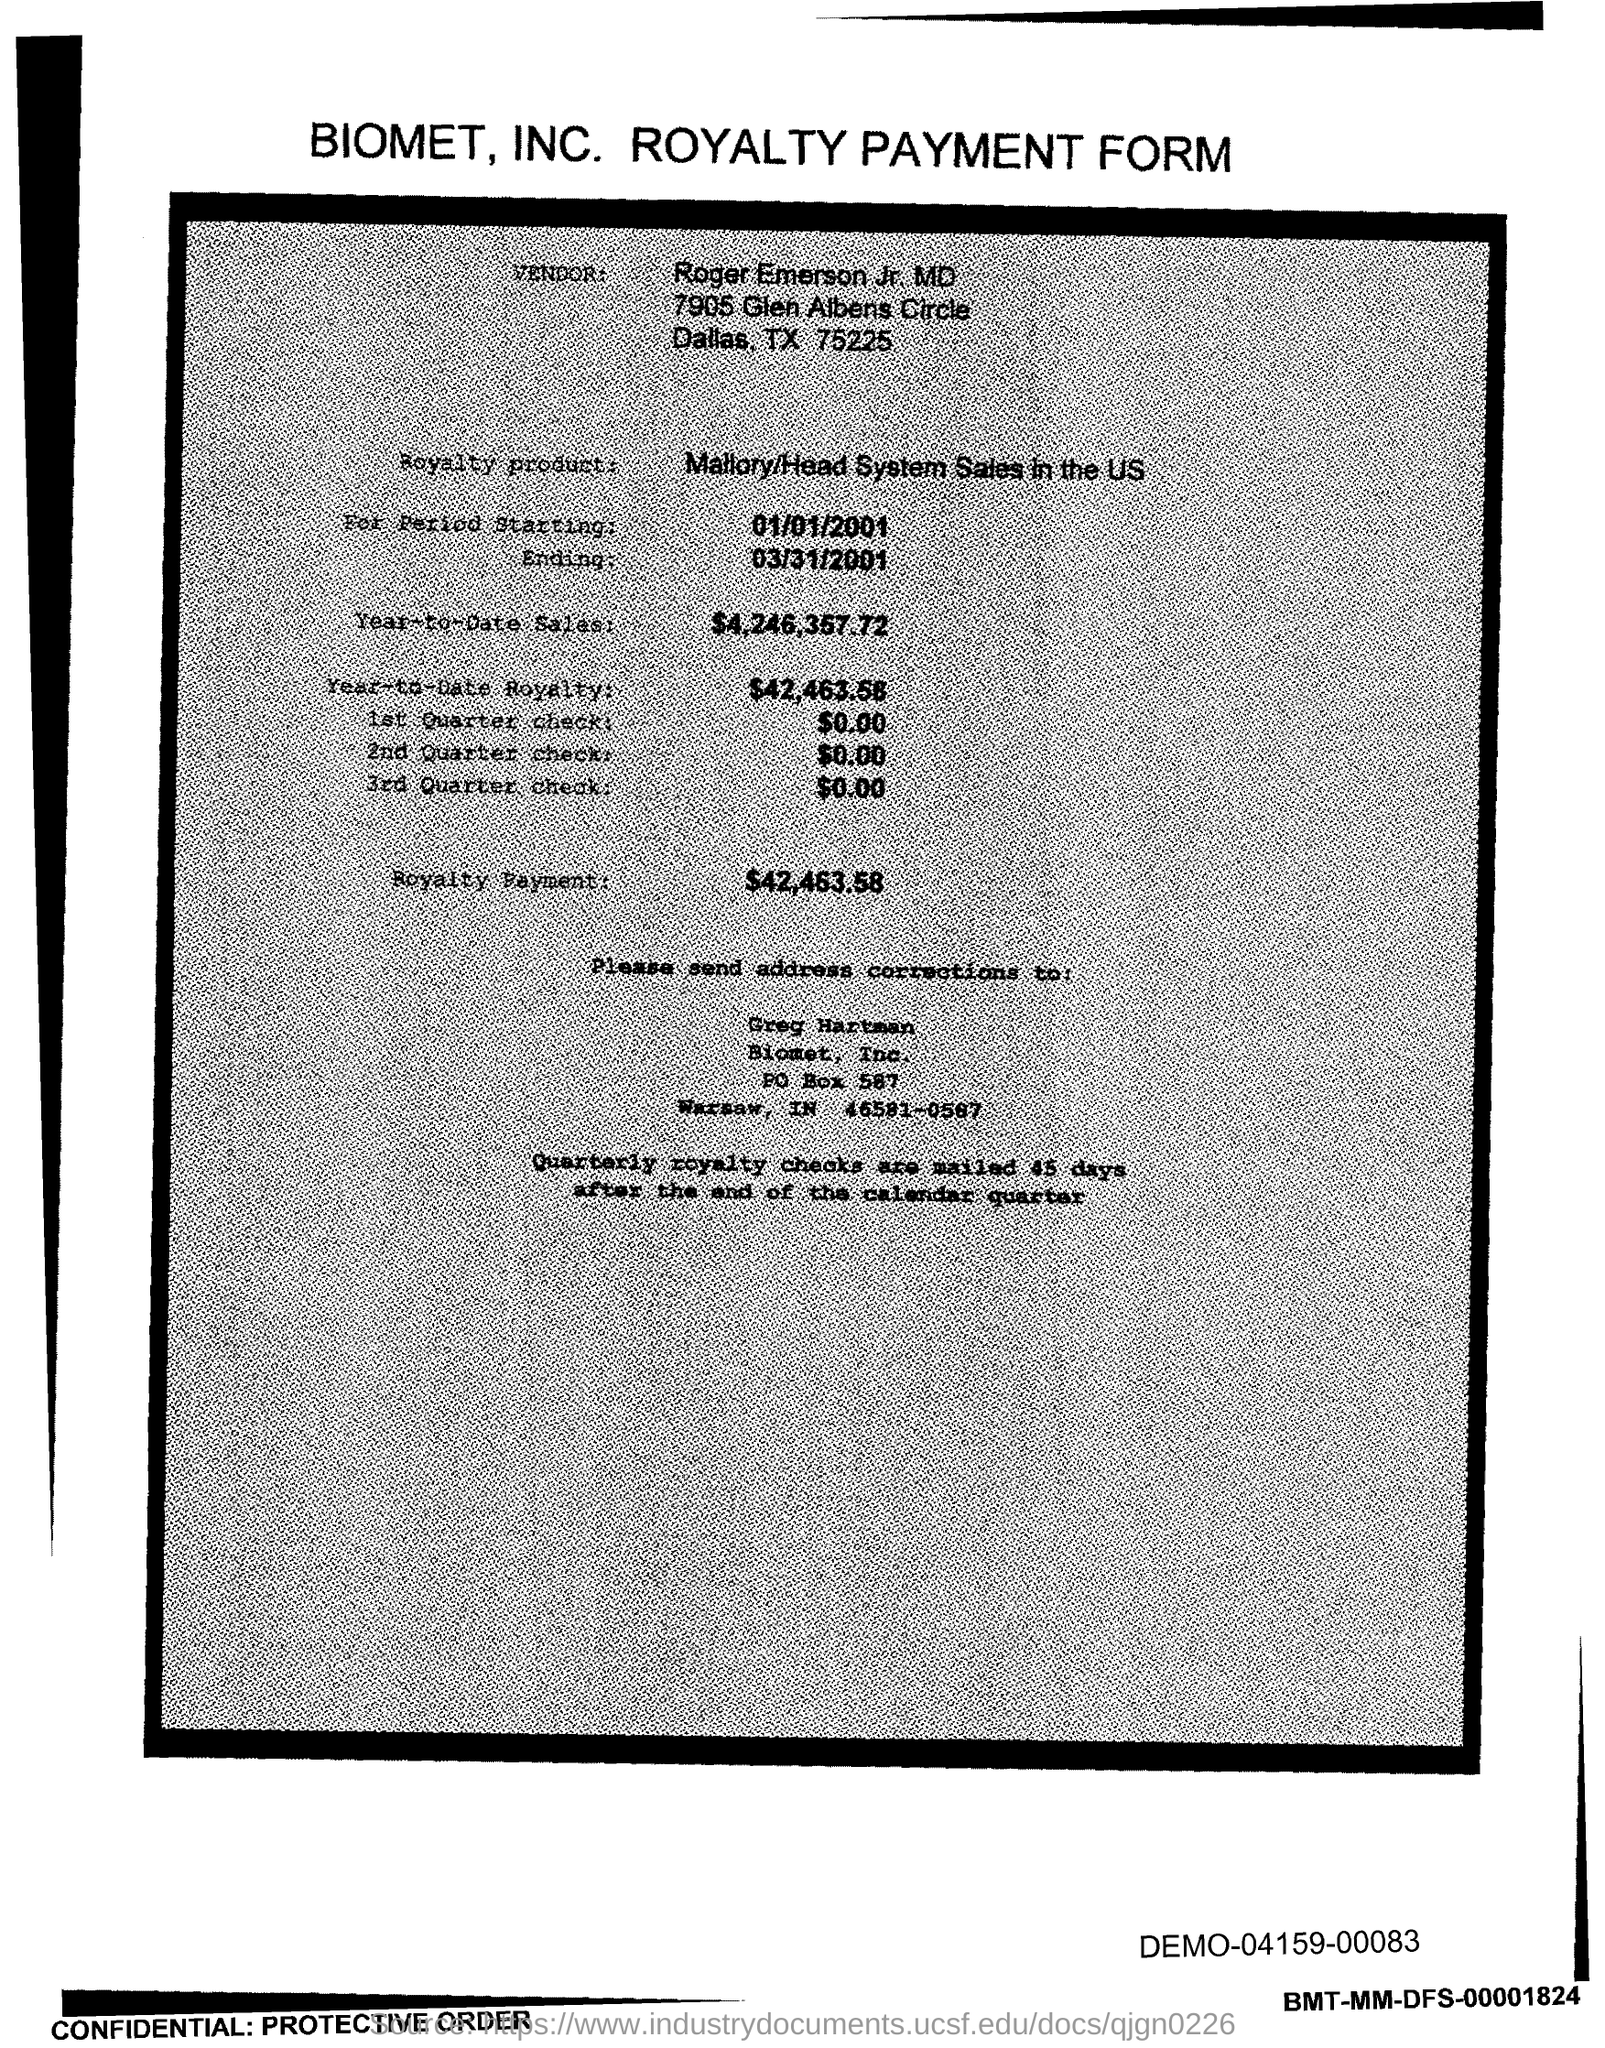Outline some significant characteristics in this image. The royalty payment is $42,463.58. The year-to-date royalty as of now is $42,463.58. Biomet, Inc. is located in the state of Indiana. The year-to-date sales as of now is $4,246,357.72. Biomet, Inc. can be reached at PO Box 587. 